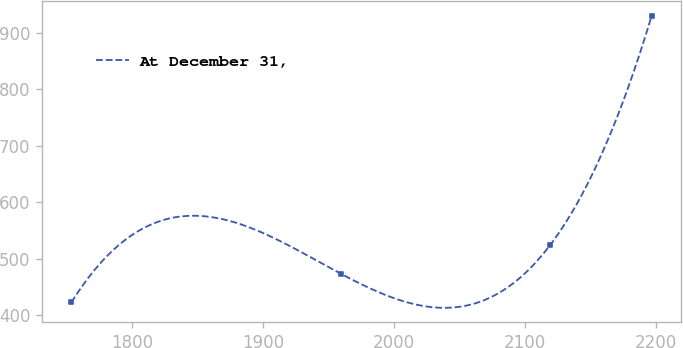<chart> <loc_0><loc_0><loc_500><loc_500><line_chart><ecel><fcel>At December 31,<nl><fcel>1753.36<fcel>422.31<nl><fcel>1959.55<fcel>473.09<nl><fcel>2119.34<fcel>523.87<nl><fcel>2196.98<fcel>930.12<nl></chart> 